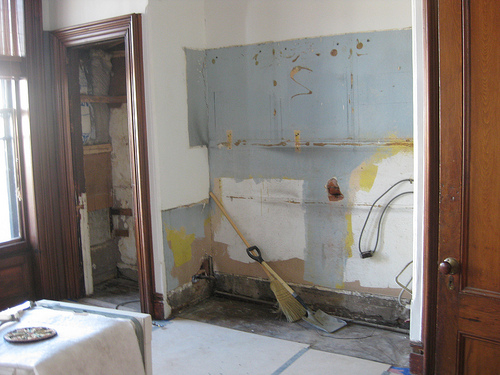<image>
Is the pipe under the wall? Yes. The pipe is positioned underneath the wall, with the wall above it in the vertical space. 